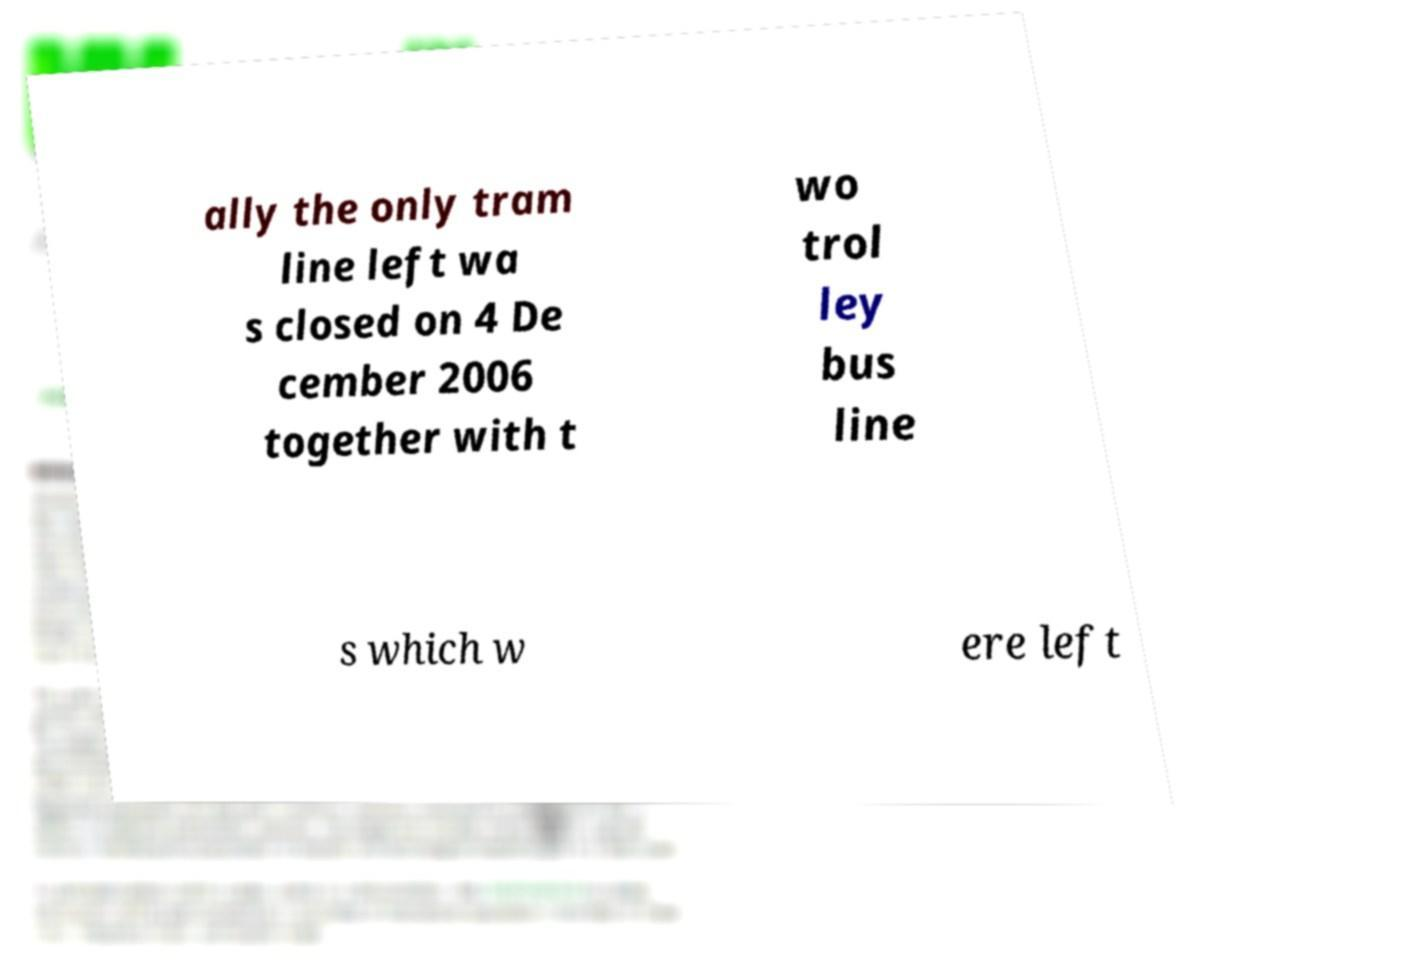Could you extract and type out the text from this image? ally the only tram line left wa s closed on 4 De cember 2006 together with t wo trol ley bus line s which w ere left 